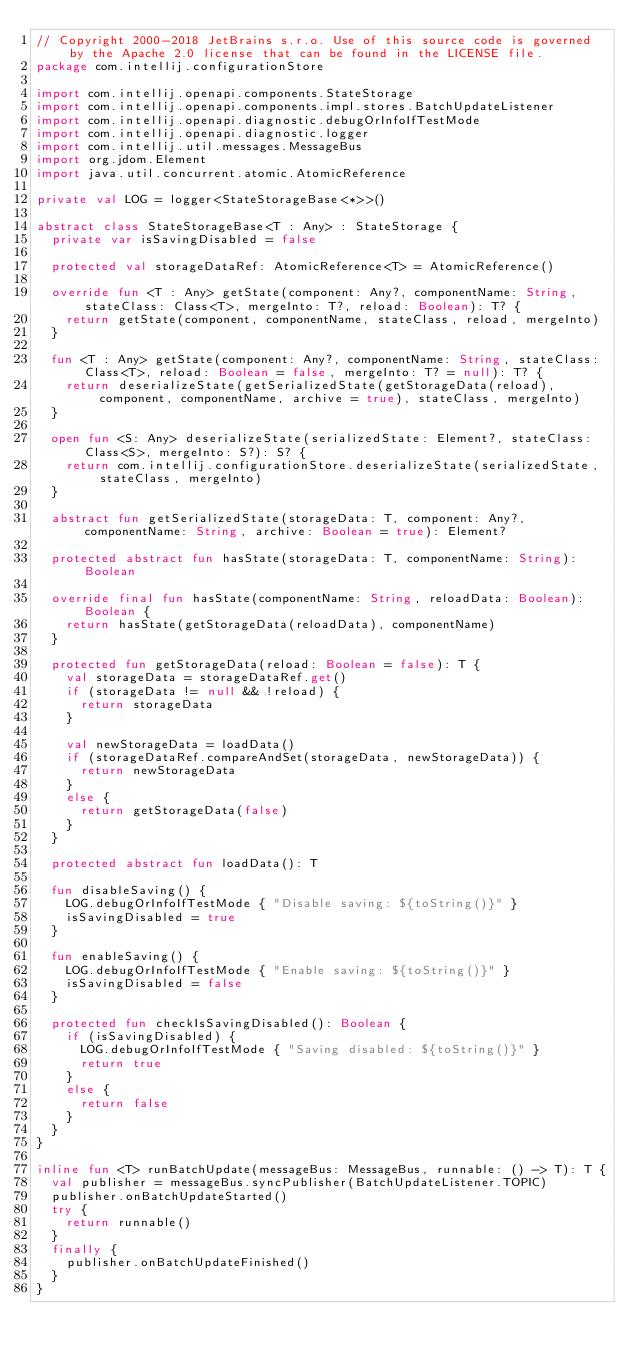<code> <loc_0><loc_0><loc_500><loc_500><_Kotlin_>// Copyright 2000-2018 JetBrains s.r.o. Use of this source code is governed by the Apache 2.0 license that can be found in the LICENSE file.
package com.intellij.configurationStore

import com.intellij.openapi.components.StateStorage
import com.intellij.openapi.components.impl.stores.BatchUpdateListener
import com.intellij.openapi.diagnostic.debugOrInfoIfTestMode
import com.intellij.openapi.diagnostic.logger
import com.intellij.util.messages.MessageBus
import org.jdom.Element
import java.util.concurrent.atomic.AtomicReference

private val LOG = logger<StateStorageBase<*>>()

abstract class StateStorageBase<T : Any> : StateStorage {
  private var isSavingDisabled = false

  protected val storageDataRef: AtomicReference<T> = AtomicReference()

  override fun <T : Any> getState(component: Any?, componentName: String, stateClass: Class<T>, mergeInto: T?, reload: Boolean): T? {
    return getState(component, componentName, stateClass, reload, mergeInto)
  }

  fun <T : Any> getState(component: Any?, componentName: String, stateClass: Class<T>, reload: Boolean = false, mergeInto: T? = null): T? {
    return deserializeState(getSerializedState(getStorageData(reload), component, componentName, archive = true), stateClass, mergeInto)
  }

  open fun <S: Any> deserializeState(serializedState: Element?, stateClass: Class<S>, mergeInto: S?): S? {
    return com.intellij.configurationStore.deserializeState(serializedState, stateClass, mergeInto)
  }

  abstract fun getSerializedState(storageData: T, component: Any?, componentName: String, archive: Boolean = true): Element?

  protected abstract fun hasState(storageData: T, componentName: String): Boolean

  override final fun hasState(componentName: String, reloadData: Boolean): Boolean {
    return hasState(getStorageData(reloadData), componentName)
  }

  protected fun getStorageData(reload: Boolean = false): T {
    val storageData = storageDataRef.get()
    if (storageData != null && !reload) {
      return storageData
    }

    val newStorageData = loadData()
    if (storageDataRef.compareAndSet(storageData, newStorageData)) {
      return newStorageData
    }
    else {
      return getStorageData(false)
    }
  }

  protected abstract fun loadData(): T

  fun disableSaving() {
    LOG.debugOrInfoIfTestMode { "Disable saving: ${toString()}" }
    isSavingDisabled = true
  }

  fun enableSaving() {
    LOG.debugOrInfoIfTestMode { "Enable saving: ${toString()}" }
    isSavingDisabled = false
  }

  protected fun checkIsSavingDisabled(): Boolean {
    if (isSavingDisabled) {
      LOG.debugOrInfoIfTestMode { "Saving disabled: ${toString()}" }
      return true
    }
    else {
      return false
    }
  }
}

inline fun <T> runBatchUpdate(messageBus: MessageBus, runnable: () -> T): T {
  val publisher = messageBus.syncPublisher(BatchUpdateListener.TOPIC)
  publisher.onBatchUpdateStarted()
  try {
    return runnable()
  }
  finally {
    publisher.onBatchUpdateFinished()
  }
}</code> 